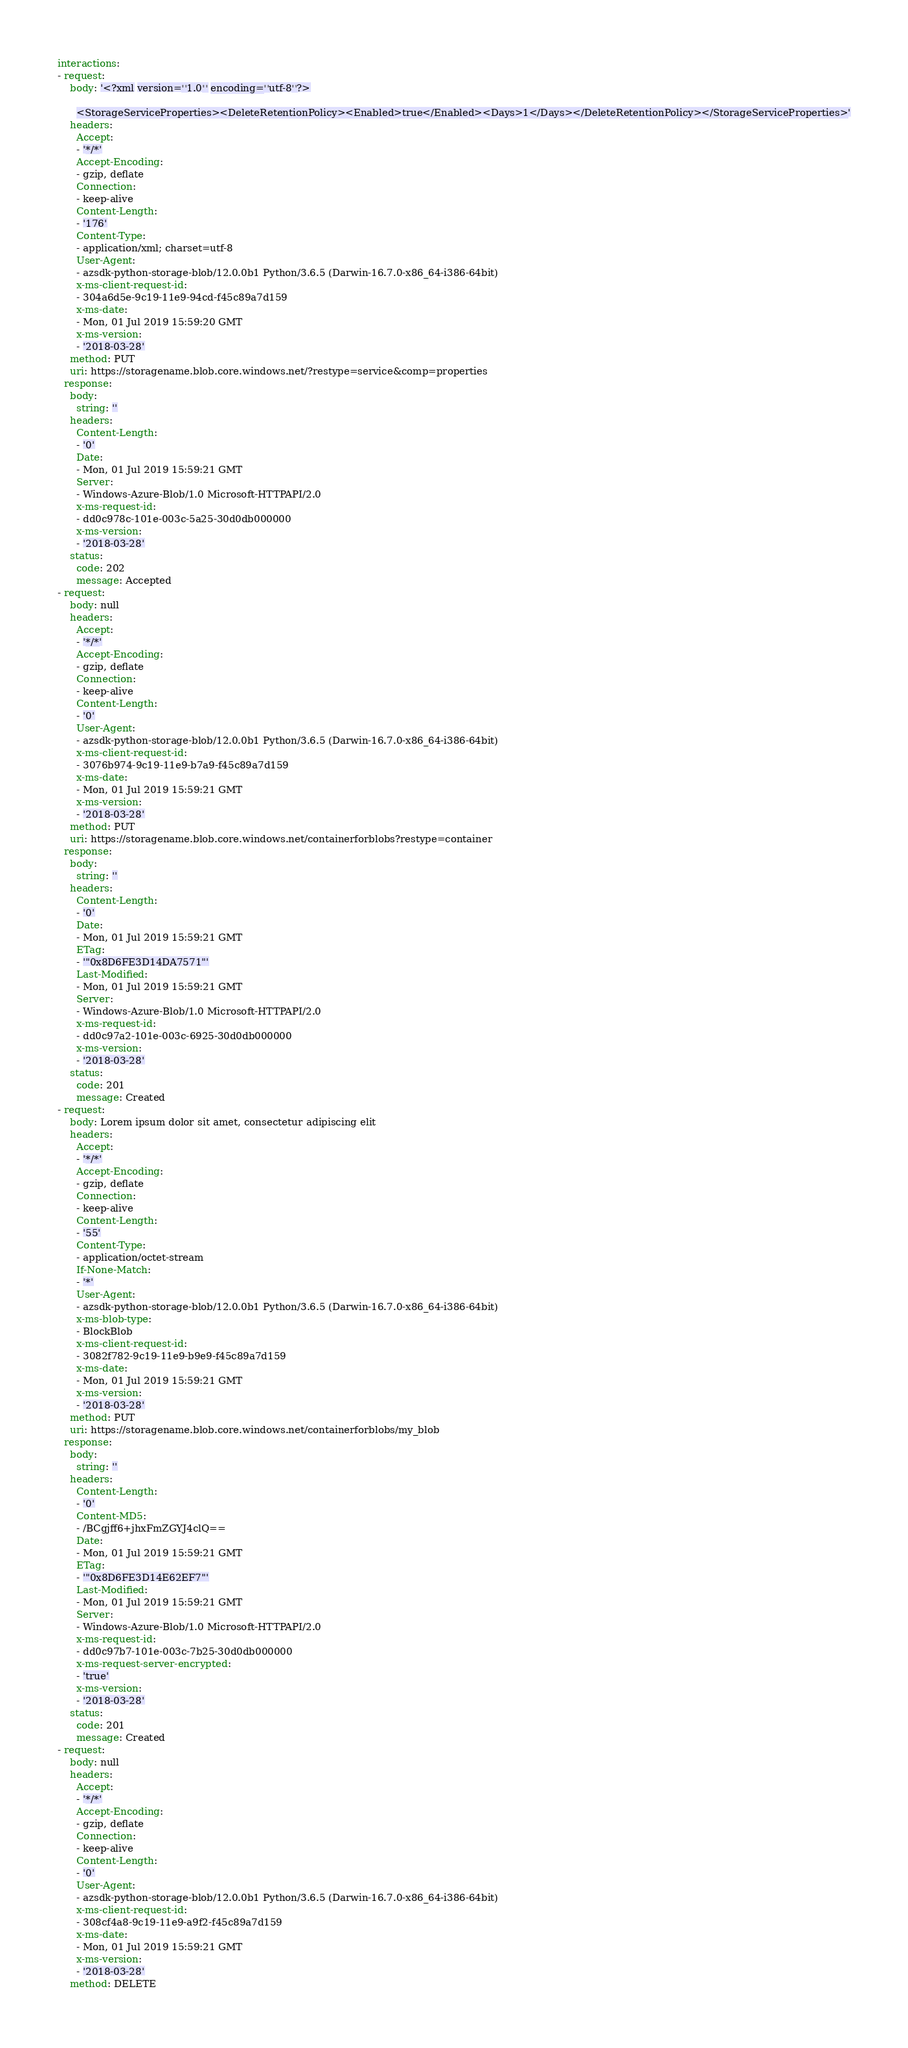Convert code to text. <code><loc_0><loc_0><loc_500><loc_500><_YAML_>interactions:
- request:
    body: '<?xml version=''1.0'' encoding=''utf-8''?>

      <StorageServiceProperties><DeleteRetentionPolicy><Enabled>true</Enabled><Days>1</Days></DeleteRetentionPolicy></StorageServiceProperties>'
    headers:
      Accept:
      - '*/*'
      Accept-Encoding:
      - gzip, deflate
      Connection:
      - keep-alive
      Content-Length:
      - '176'
      Content-Type:
      - application/xml; charset=utf-8
      User-Agent:
      - azsdk-python-storage-blob/12.0.0b1 Python/3.6.5 (Darwin-16.7.0-x86_64-i386-64bit)
      x-ms-client-request-id:
      - 304a6d5e-9c19-11e9-94cd-f45c89a7d159
      x-ms-date:
      - Mon, 01 Jul 2019 15:59:20 GMT
      x-ms-version:
      - '2018-03-28'
    method: PUT
    uri: https://storagename.blob.core.windows.net/?restype=service&comp=properties
  response:
    body:
      string: ''
    headers:
      Content-Length:
      - '0'
      Date:
      - Mon, 01 Jul 2019 15:59:21 GMT
      Server:
      - Windows-Azure-Blob/1.0 Microsoft-HTTPAPI/2.0
      x-ms-request-id:
      - dd0c978c-101e-003c-5a25-30d0db000000
      x-ms-version:
      - '2018-03-28'
    status:
      code: 202
      message: Accepted
- request:
    body: null
    headers:
      Accept:
      - '*/*'
      Accept-Encoding:
      - gzip, deflate
      Connection:
      - keep-alive
      Content-Length:
      - '0'
      User-Agent:
      - azsdk-python-storage-blob/12.0.0b1 Python/3.6.5 (Darwin-16.7.0-x86_64-i386-64bit)
      x-ms-client-request-id:
      - 3076b974-9c19-11e9-b7a9-f45c89a7d159
      x-ms-date:
      - Mon, 01 Jul 2019 15:59:21 GMT
      x-ms-version:
      - '2018-03-28'
    method: PUT
    uri: https://storagename.blob.core.windows.net/containerforblobs?restype=container
  response:
    body:
      string: ''
    headers:
      Content-Length:
      - '0'
      Date:
      - Mon, 01 Jul 2019 15:59:21 GMT
      ETag:
      - '"0x8D6FE3D14DA7571"'
      Last-Modified:
      - Mon, 01 Jul 2019 15:59:21 GMT
      Server:
      - Windows-Azure-Blob/1.0 Microsoft-HTTPAPI/2.0
      x-ms-request-id:
      - dd0c97a2-101e-003c-6925-30d0db000000
      x-ms-version:
      - '2018-03-28'
    status:
      code: 201
      message: Created
- request:
    body: Lorem ipsum dolor sit amet, consectetur adipiscing elit
    headers:
      Accept:
      - '*/*'
      Accept-Encoding:
      - gzip, deflate
      Connection:
      - keep-alive
      Content-Length:
      - '55'
      Content-Type:
      - application/octet-stream
      If-None-Match:
      - '*'
      User-Agent:
      - azsdk-python-storage-blob/12.0.0b1 Python/3.6.5 (Darwin-16.7.0-x86_64-i386-64bit)
      x-ms-blob-type:
      - BlockBlob
      x-ms-client-request-id:
      - 3082f782-9c19-11e9-b9e9-f45c89a7d159
      x-ms-date:
      - Mon, 01 Jul 2019 15:59:21 GMT
      x-ms-version:
      - '2018-03-28'
    method: PUT
    uri: https://storagename.blob.core.windows.net/containerforblobs/my_blob
  response:
    body:
      string: ''
    headers:
      Content-Length:
      - '0'
      Content-MD5:
      - /BCgjff6+jhxFmZGYJ4clQ==
      Date:
      - Mon, 01 Jul 2019 15:59:21 GMT
      ETag:
      - '"0x8D6FE3D14E62EF7"'
      Last-Modified:
      - Mon, 01 Jul 2019 15:59:21 GMT
      Server:
      - Windows-Azure-Blob/1.0 Microsoft-HTTPAPI/2.0
      x-ms-request-id:
      - dd0c97b7-101e-003c-7b25-30d0db000000
      x-ms-request-server-encrypted:
      - 'true'
      x-ms-version:
      - '2018-03-28'
    status:
      code: 201
      message: Created
- request:
    body: null
    headers:
      Accept:
      - '*/*'
      Accept-Encoding:
      - gzip, deflate
      Connection:
      - keep-alive
      Content-Length:
      - '0'
      User-Agent:
      - azsdk-python-storage-blob/12.0.0b1 Python/3.6.5 (Darwin-16.7.0-x86_64-i386-64bit)
      x-ms-client-request-id:
      - 308cf4a8-9c19-11e9-a9f2-f45c89a7d159
      x-ms-date:
      - Mon, 01 Jul 2019 15:59:21 GMT
      x-ms-version:
      - '2018-03-28'
    method: DELETE</code> 